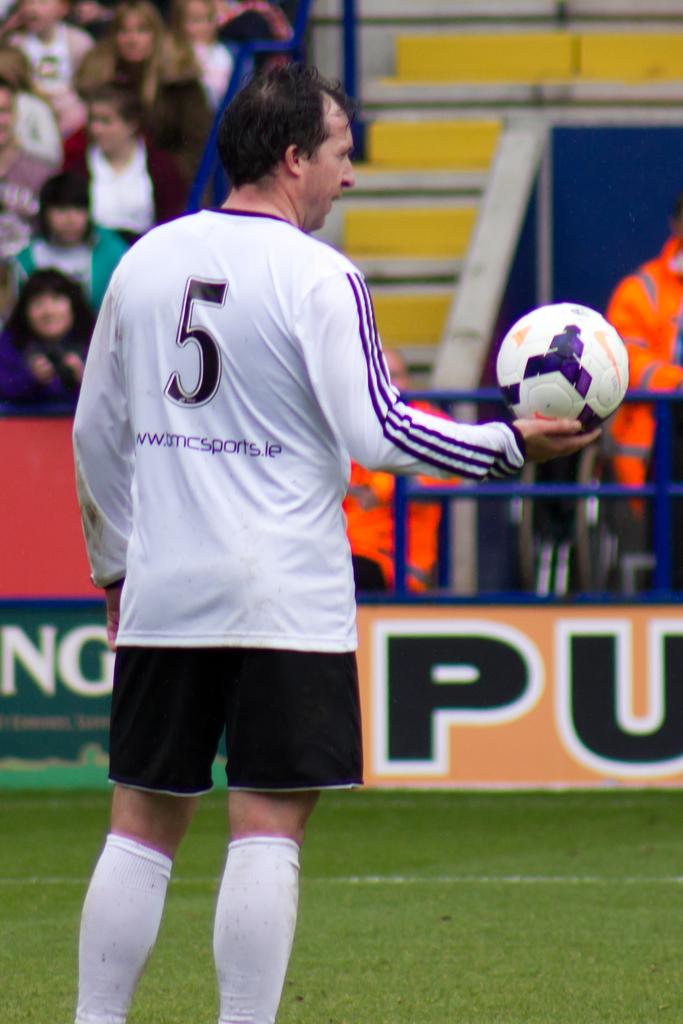What number is the player with the ball?
Provide a succinct answer. 5. What is the first letter on the green banner?
Offer a very short reply. N. 